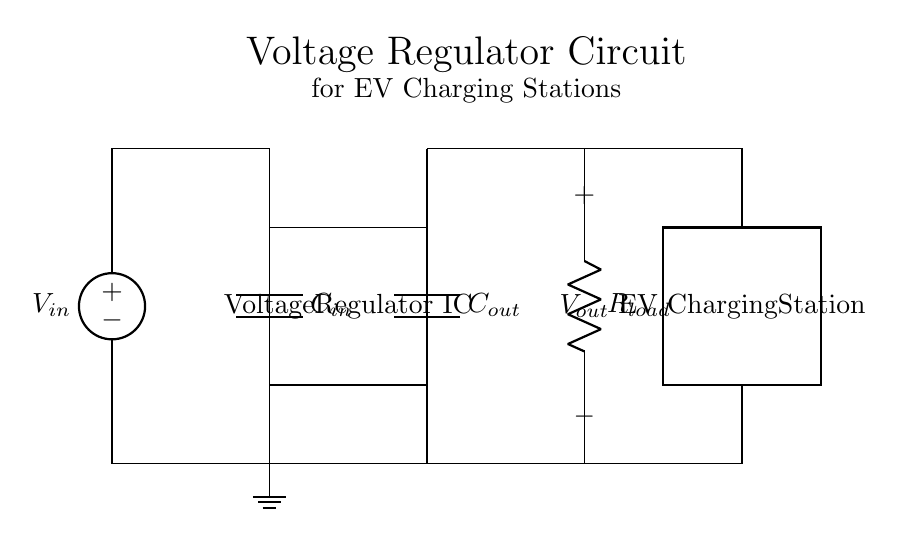What is the input voltage in the circuit? The input voltage is labeled as V_in, which is the supply voltage provided to the circuit. It is represented at the left side of the diagram.
Answer: V_in What is the purpose of the capacitors C_in and C_out? C_in is used to stabilize the input voltage, reducing ripple, while C_out smooths the output voltage to maintain stability for the load.
Answer: Stabilization What type of component is the Voltage Regulator IC? The Voltage Regulator IC is an integrated circuit intended to regulate and stabilize the output voltage regardless of variations in the input voltage or load conditions.
Answer: Integrated circuit How does the load resistor affect the output voltage? The load resistor, labeled R_load, draws current from the output, affecting the voltage across it based on the current drawn, hence influencing the overall performance of the regulator.
Answer: It influences output What is the voltage across the output connection? The output voltage is indicated by V_out, which is the voltage provided to the load connected at the output of the regulator. It can vary based on the input voltage and load conditions but is maintained within a specific range by the regulator.
Answer: V_out What type of circuit is primarily being illustrated here? The circuit illustrated is a voltage regulator circuit, specifically designed to provide a stable output voltage ideal for powering electric vehicle charging stations.
Answer: Voltage regulator circuit 